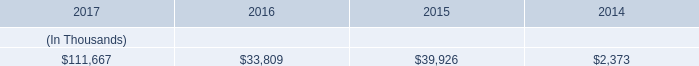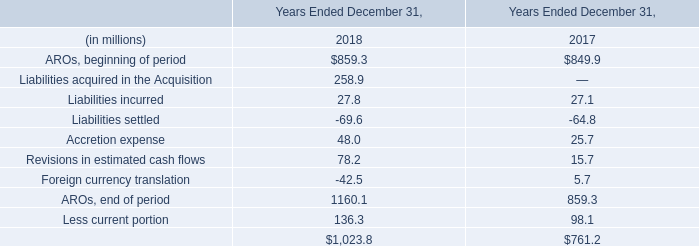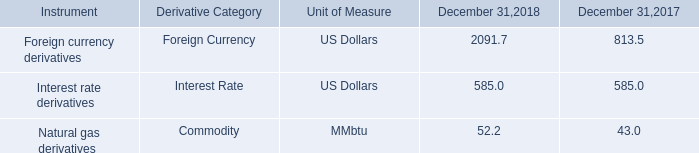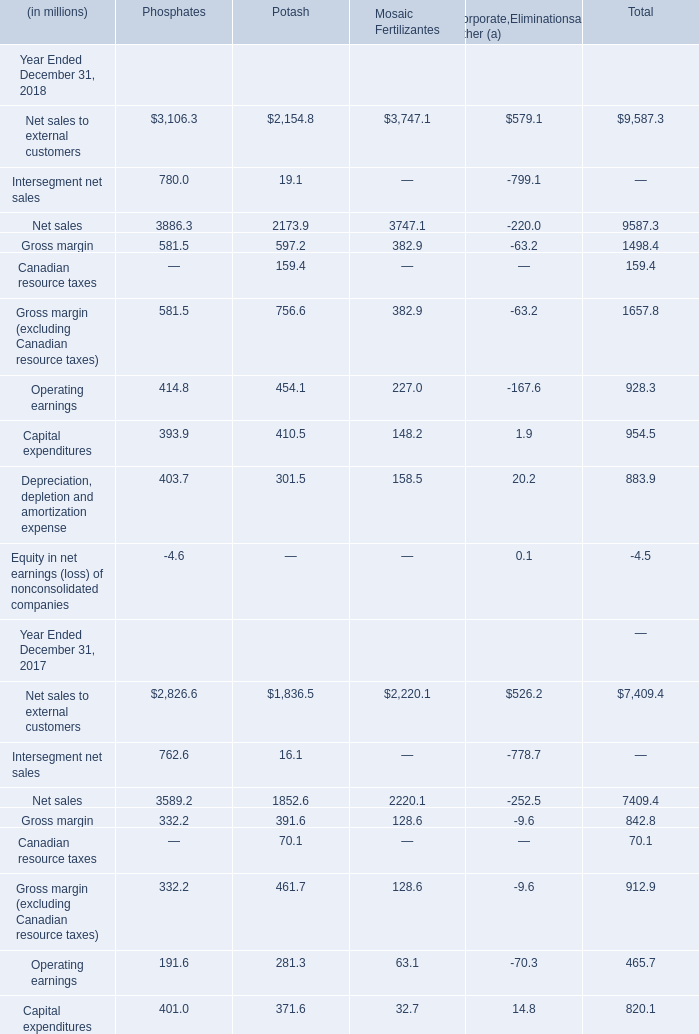In the year with the most Natural gas derivatives in Table 2, what is the growth rate of Liabilities incurred in Table 1? 
Computations: ((27.8 - 27.1) / 27.1)
Answer: 0.02583. How many Net sales exceed the average of Net sales to external customers in 2018? 
Answer: 2. as of december 31 , 2017 what was the percent of the system energy credit facility utilization 
Computations: ((17.8 + 50) / 120)
Answer: 0.565. 